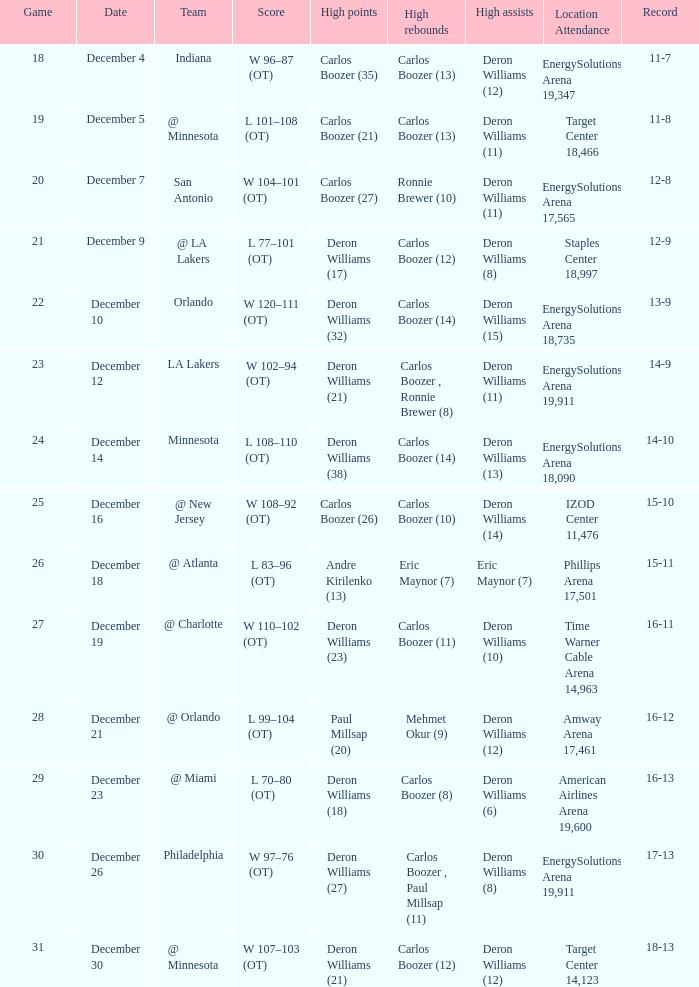What's the number of the game in which Carlos Boozer (8) did the high rebounds? 29.0. 